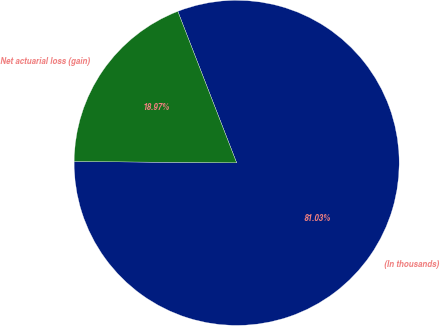Convert chart to OTSL. <chart><loc_0><loc_0><loc_500><loc_500><pie_chart><fcel>(In thousands)<fcel>Net actuarial loss (gain)<nl><fcel>81.03%<fcel>18.97%<nl></chart> 